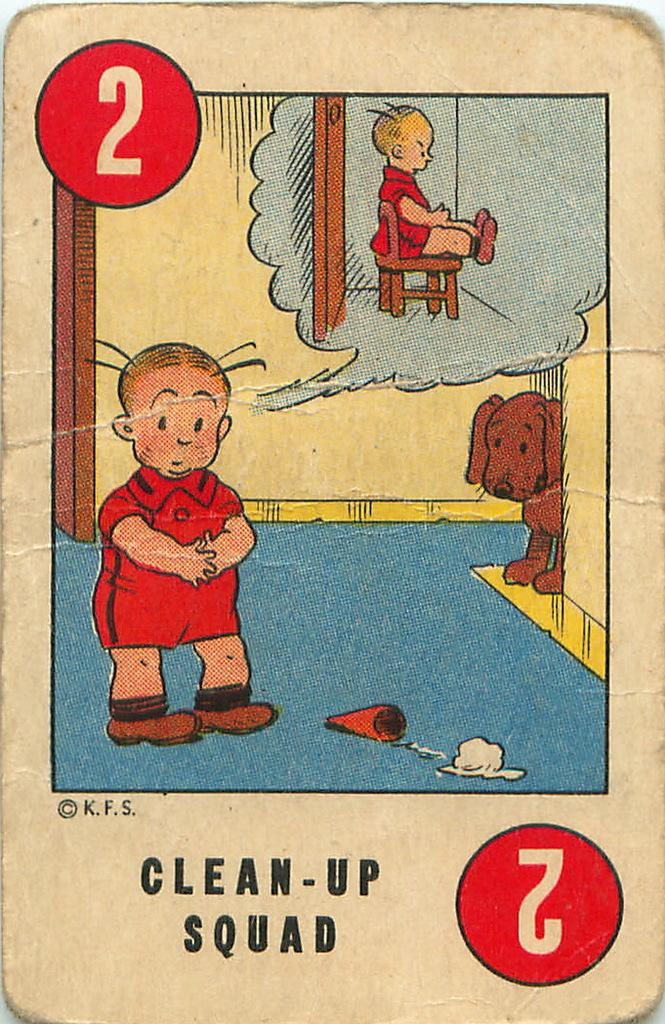What is featured on the poster in the image? There is a poster in the image that has text and drawings on it. Can you describe the drawings on the poster? The poster has a drawing of a kid and a drawing of a dog on it. What color is the blood on the poster? There is no blood present on the poster; it features a drawing of a kid and a dog. What type of ray is depicted in the image? There is no ray depicted in the image; the poster has text and drawings of a kid and a dog. 